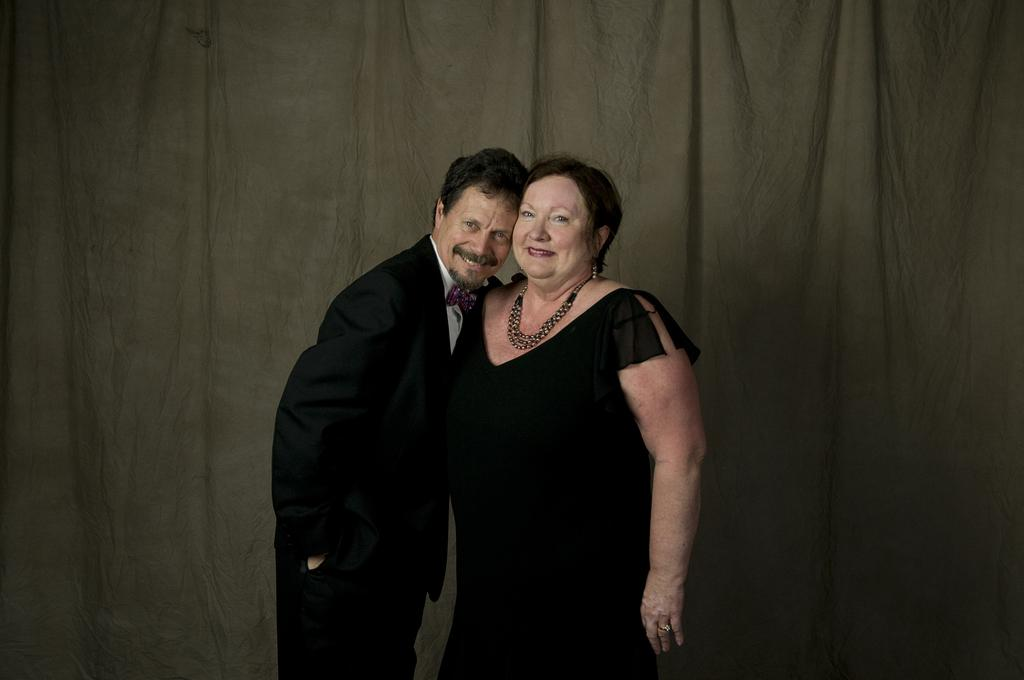Who are the main subjects in the picture? There is an old couple in the picture. Where are the old couple positioned in the image? The old couple is standing in the front. What are the old couple wearing? The old man is wearing a black suit, and the old woman is wearing a black dress. What is the emotional expression of the old couple? The old couple is smiling. What are the old couple doing in the image? The old couple is giving a pose to the camera. What can be seen in the background of the image? There is a grey curtain in the background. What type of destruction can be seen happening in the background of the image? There is no destruction visible in the image; it features an old couple posing for a photo with a grey curtain in the background. What color of ink is being used by the old couple to write their names on the photo? There is no indication in the image that the old couple is writing their names or using ink. 